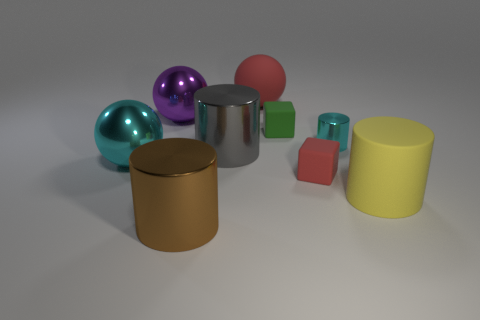Subtract all big shiny balls. How many balls are left? 1 Add 1 green rubber cubes. How many objects exist? 10 Subtract 1 cylinders. How many cylinders are left? 3 Subtract all purple spheres. How many spheres are left? 2 Subtract 0 blue blocks. How many objects are left? 9 Subtract all cubes. How many objects are left? 7 Subtract all cyan cubes. Subtract all red spheres. How many cubes are left? 2 Subtract all gray cylinders. How many cyan spheres are left? 1 Subtract all matte objects. Subtract all small green metallic spheres. How many objects are left? 5 Add 9 big purple shiny objects. How many big purple shiny objects are left? 10 